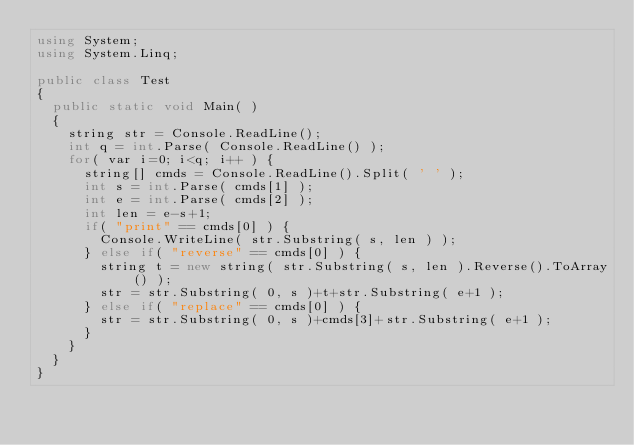Convert code to text. <code><loc_0><loc_0><loc_500><loc_500><_C++_>using System;
using System.Linq;

public class Test
{
	public static void Main( )
	{
		string str = Console.ReadLine();
		int q = int.Parse( Console.ReadLine() );
		for( var i=0; i<q; i++ ) {
			string[] cmds = Console.ReadLine().Split( ' ' );
			int s = int.Parse( cmds[1] );
			int e = int.Parse( cmds[2] );
			int len = e-s+1;
			if( "print" == cmds[0] ) {
				Console.WriteLine( str.Substring( s, len ) );
			} else if( "reverse" == cmds[0] ) {
				string t = new string( str.Substring( s, len ).Reverse().ToArray() );
				str = str.Substring( 0, s )+t+str.Substring( e+1 );
			} else if( "replace" == cmds[0] ) {
				str = str.Substring( 0, s )+cmds[3]+str.Substring( e+1 );
			}
		}
	}
}</code> 